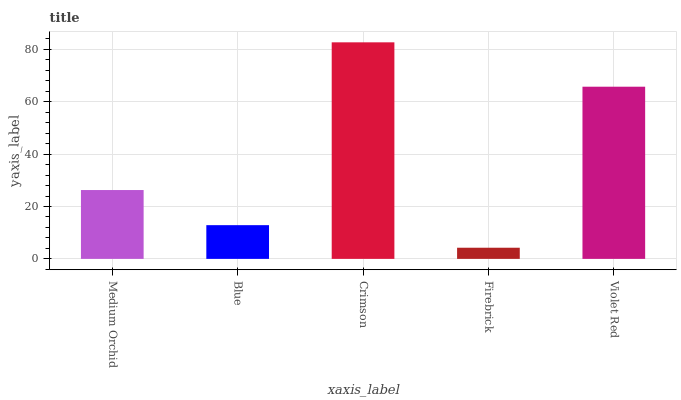Is Firebrick the minimum?
Answer yes or no. Yes. Is Crimson the maximum?
Answer yes or no. Yes. Is Blue the minimum?
Answer yes or no. No. Is Blue the maximum?
Answer yes or no. No. Is Medium Orchid greater than Blue?
Answer yes or no. Yes. Is Blue less than Medium Orchid?
Answer yes or no. Yes. Is Blue greater than Medium Orchid?
Answer yes or no. No. Is Medium Orchid less than Blue?
Answer yes or no. No. Is Medium Orchid the high median?
Answer yes or no. Yes. Is Medium Orchid the low median?
Answer yes or no. Yes. Is Firebrick the high median?
Answer yes or no. No. Is Crimson the low median?
Answer yes or no. No. 